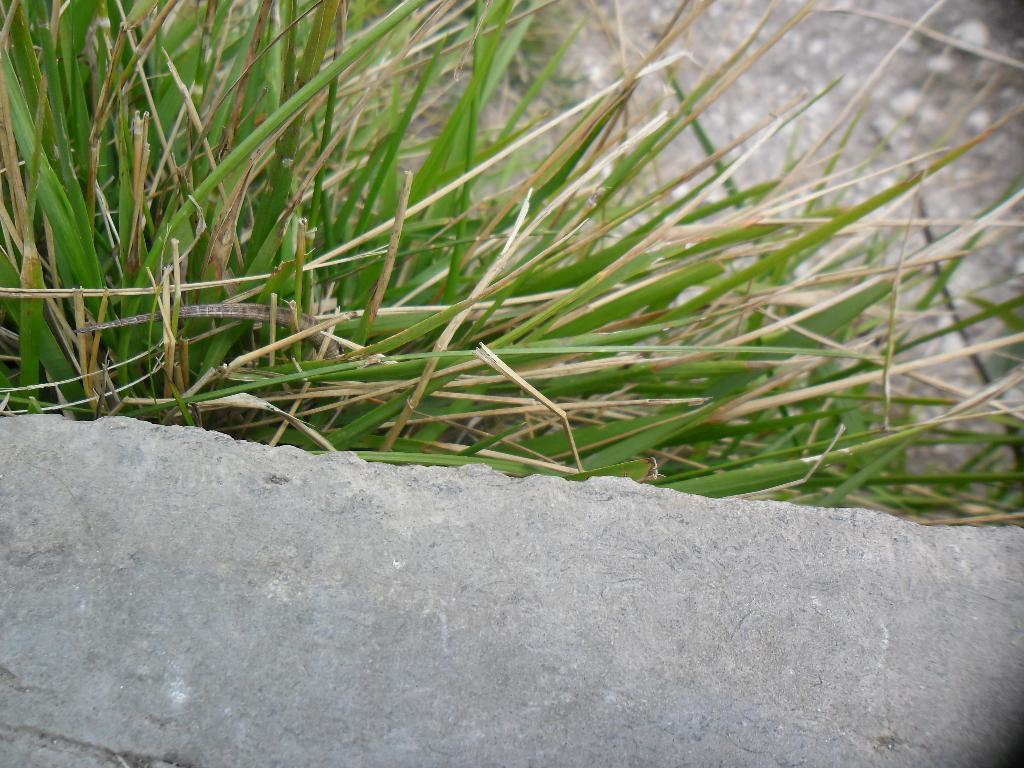What type of vegetation can be seen in the image? There is grass in the image. What else can be seen in the image besides the grass? There are other objects in the image. Can you describe the background of the image? The background of the image is blurred. What type of wax is being used to wrap the parcel in the image? There is no parcel or wax present in the image. What level of difficulty can be seen in the image? The image does not depict any level of difficulty or challenge. 